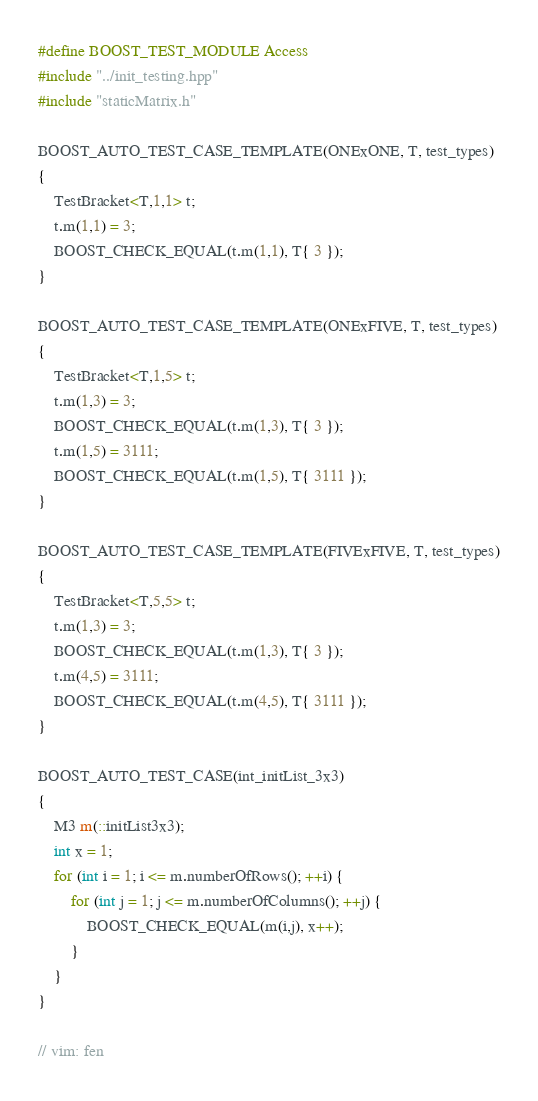Convert code to text. <code><loc_0><loc_0><loc_500><loc_500><_C++_>#define BOOST_TEST_MODULE Access
#include "../init_testing.hpp"
#include "staticMatrix.h"

BOOST_AUTO_TEST_CASE_TEMPLATE(ONExONE, T, test_types)
{
    TestBracket<T,1,1> t;
    t.m(1,1) = 3;
    BOOST_CHECK_EQUAL(t.m(1,1), T{ 3 });
}

BOOST_AUTO_TEST_CASE_TEMPLATE(ONExFIVE, T, test_types)
{
    TestBracket<T,1,5> t;
    t.m(1,3) = 3;
    BOOST_CHECK_EQUAL(t.m(1,3), T{ 3 });
    t.m(1,5) = 3111;
    BOOST_CHECK_EQUAL(t.m(1,5), T{ 3111 });
}

BOOST_AUTO_TEST_CASE_TEMPLATE(FIVExFIVE, T, test_types)
{
    TestBracket<T,5,5> t;
    t.m(1,3) = 3;
    BOOST_CHECK_EQUAL(t.m(1,3), T{ 3 });
    t.m(4,5) = 3111;
    BOOST_CHECK_EQUAL(t.m(4,5), T{ 3111 });
}

BOOST_AUTO_TEST_CASE(int_initList_3x3)
{
    M3 m(::initList3x3);
    int x = 1;
    for (int i = 1; i <= m.numberOfRows(); ++i) {
        for (int j = 1; j <= m.numberOfColumns(); ++j) {
            BOOST_CHECK_EQUAL(m(i,j), x++);
        }
    }
}

// vim: fen
</code> 